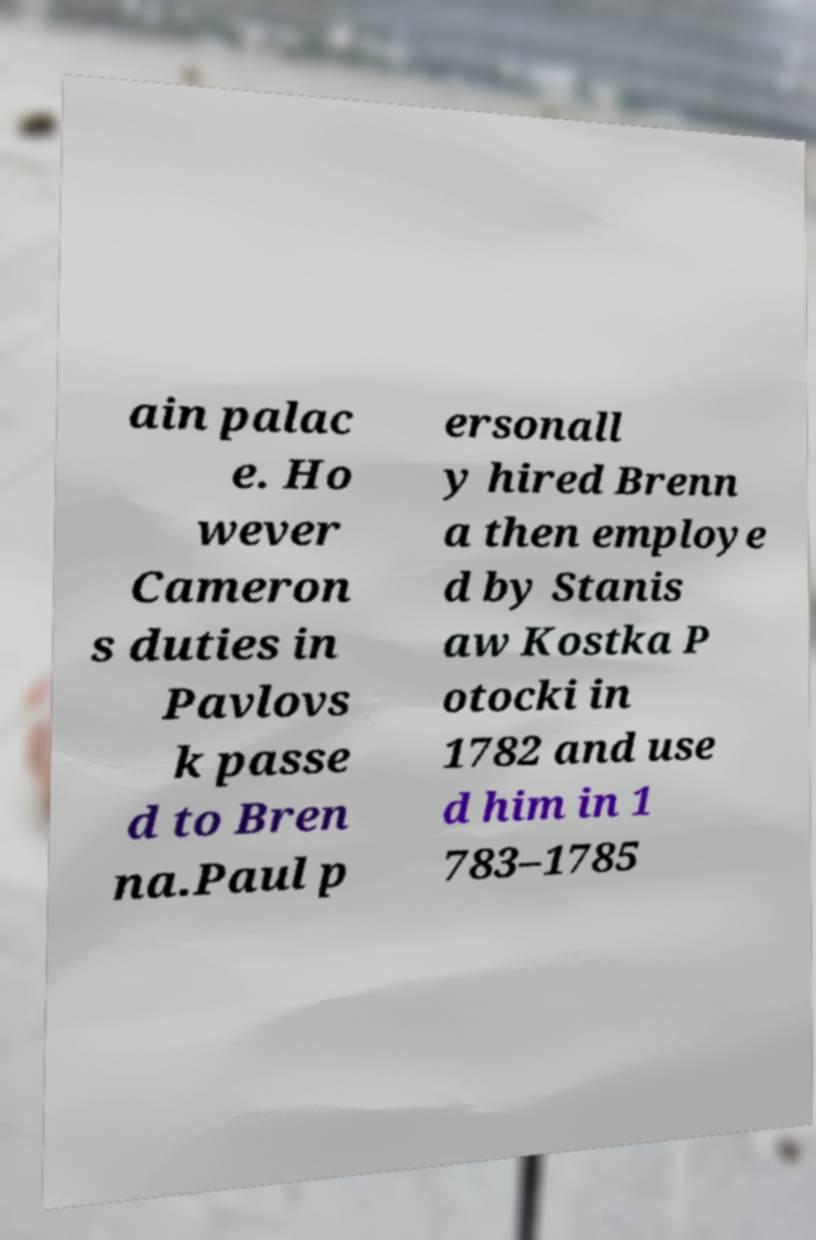Please read and relay the text visible in this image. What does it say? ain palac e. Ho wever Cameron s duties in Pavlovs k passe d to Bren na.Paul p ersonall y hired Brenn a then employe d by Stanis aw Kostka P otocki in 1782 and use d him in 1 783–1785 